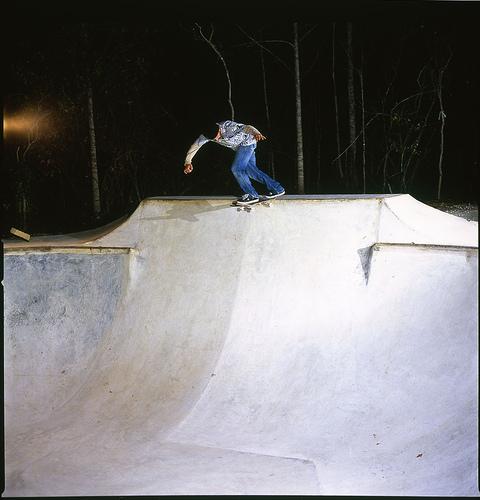How many skateboards are there?
Write a very short answer. 1. Is this a skate park?
Quick response, please. Yes. Do the trees have leaves?
Short answer required. No. 